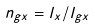<formula> <loc_0><loc_0><loc_500><loc_500>n _ { g x } = l _ { x } / l _ { g x }</formula> 